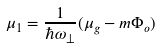Convert formula to latex. <formula><loc_0><loc_0><loc_500><loc_500>\mu _ { 1 } = \frac { 1 } { \hbar { \omega } _ { \perp } } ( \mu _ { g } - m \Phi _ { o } )</formula> 